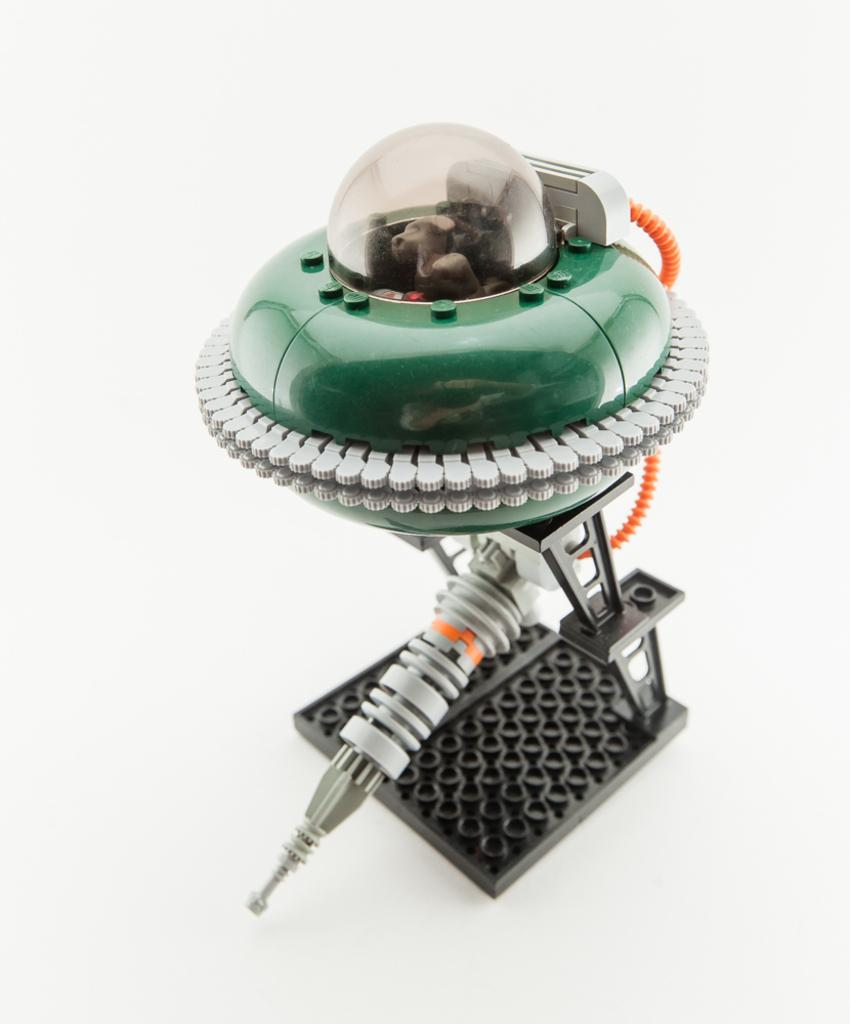What is the main subject of the image? There is an object in the image that resembles a robot. What can be seen in the background of the image? The background of the image is white. What actor is playing the role of the robot in the image? There is no actor or role-playing in the image; it simply features an object that resembles a robot. 